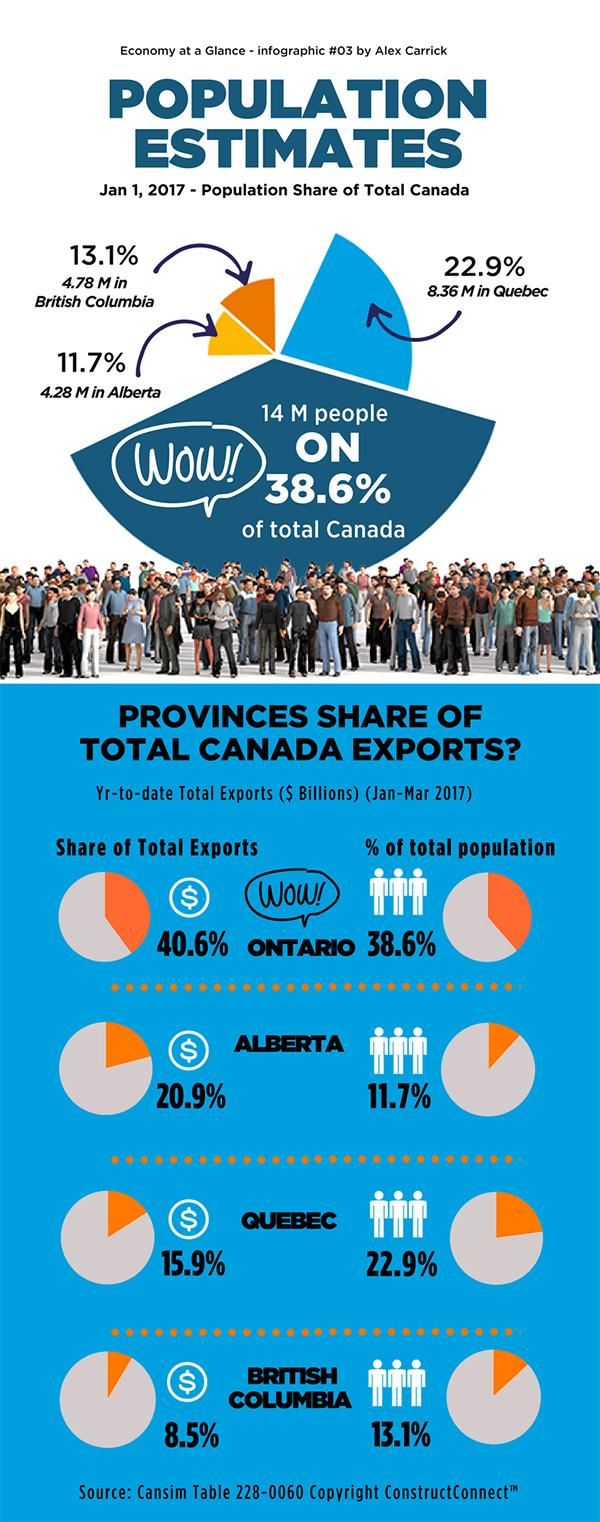Mention a couple of crucial points in this snapshot. Quebec and British Columbia together account for 24.4% of total exports. According to the given information, the population of British Columbia and Quebec taken together is 13.14 million. In total, the population of Ontario and Alberta combined is approximately 50.3% of the population in the two provinces. In Quebec and British Columbia taken together, the population accounts for 36% of the total population of Canada. The combined share of Ontario and Alberta in total exports is 61.5%. 